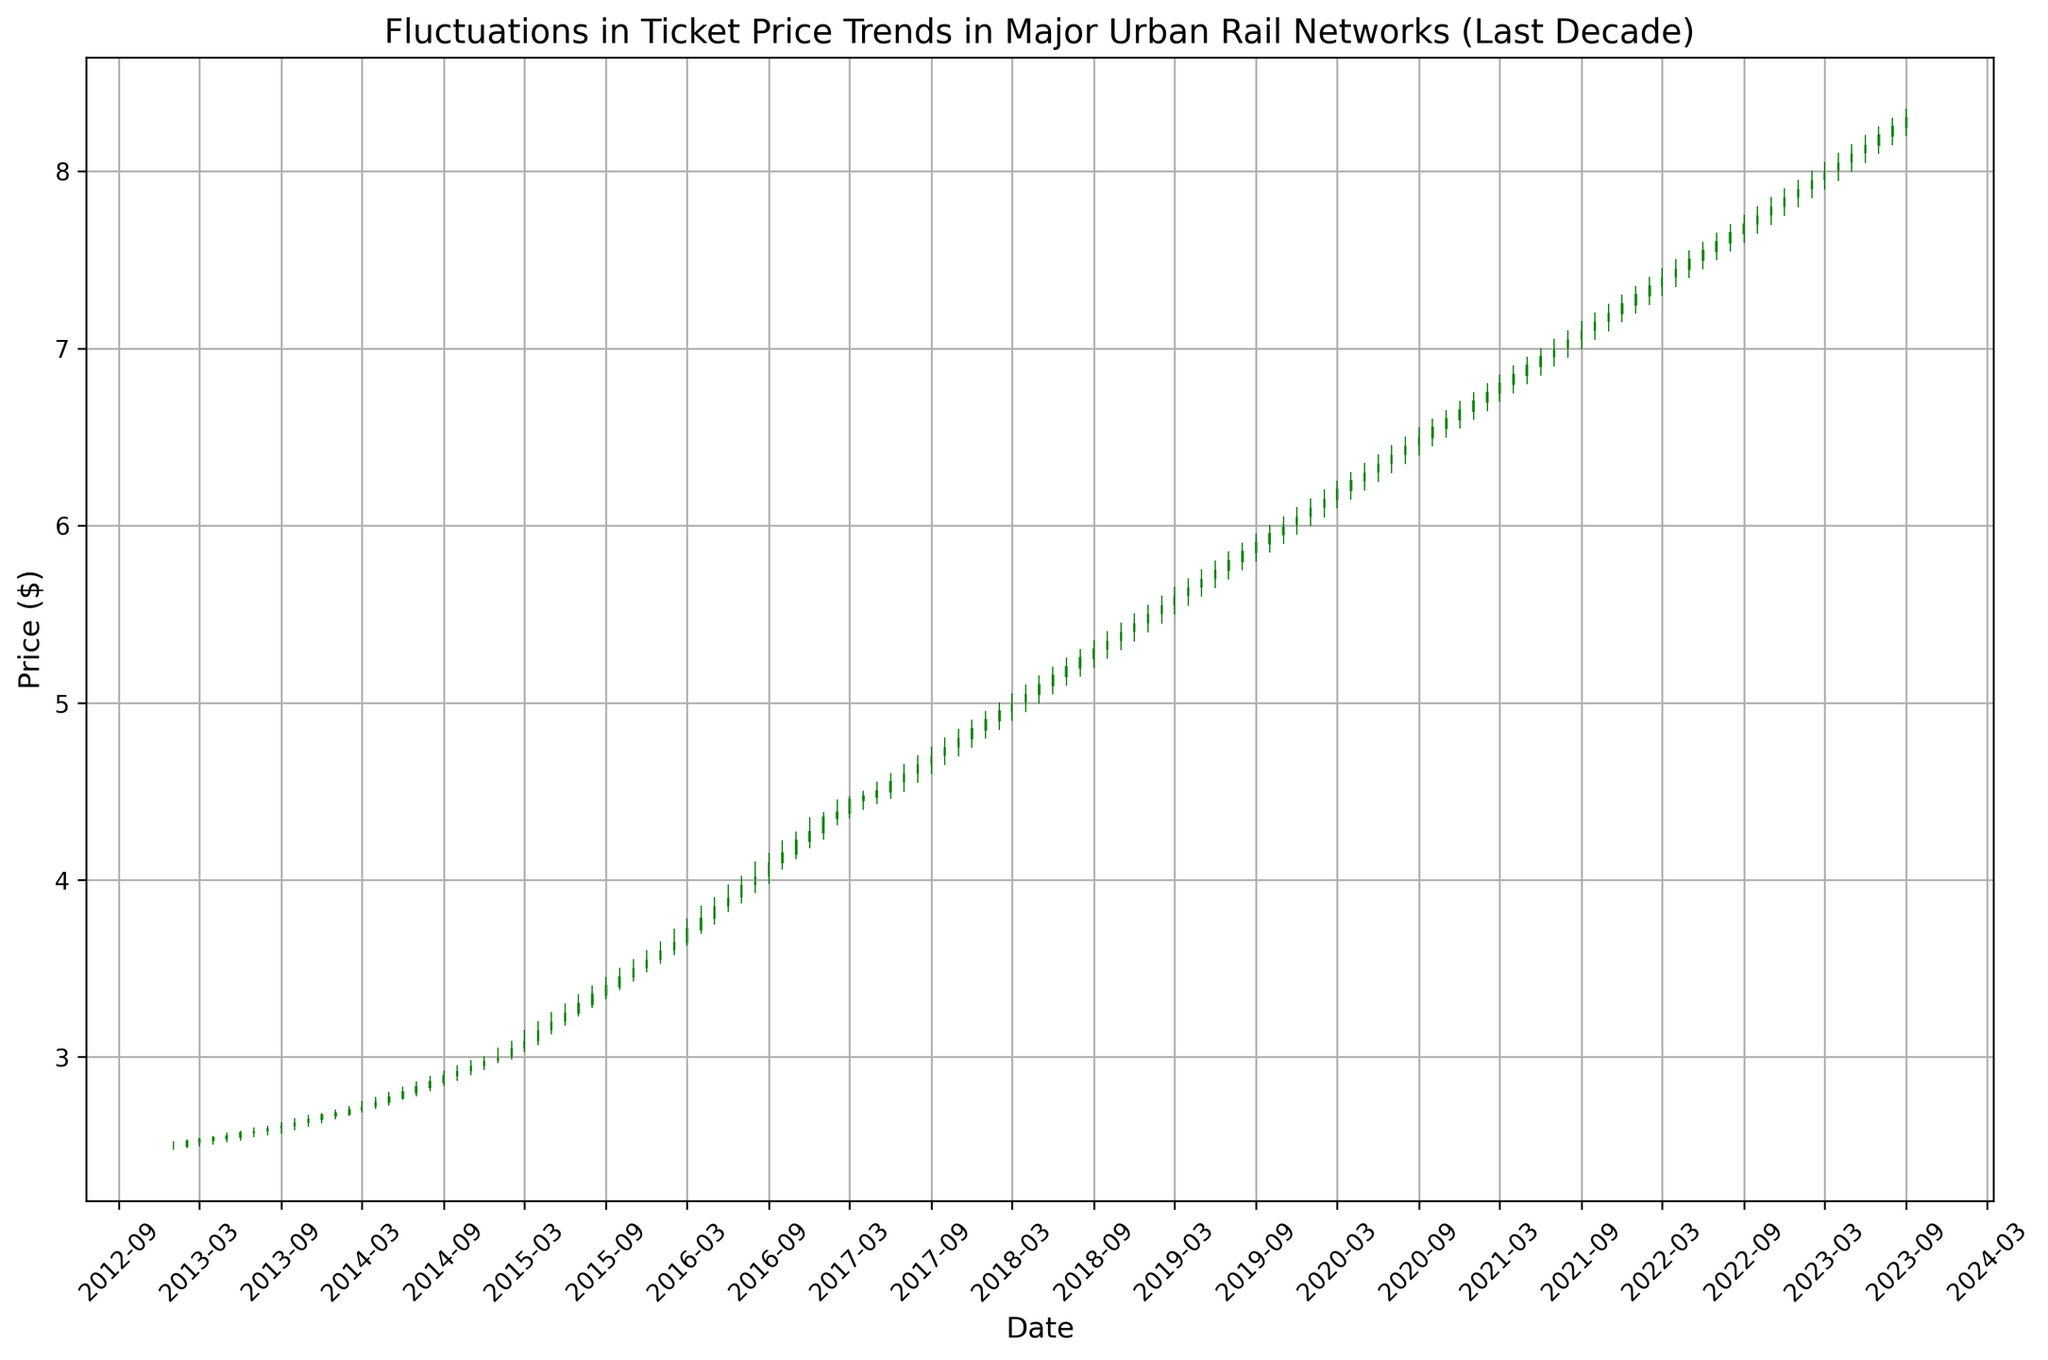What is the highest ticket price recorded in the data? To find the highest ticket price, observe the maximum value in the high-price candlestick plots, which visually represent peak prices for each month.
Answer: 8.35 Between January 2015 and January 2016, in which month did the closing ticket price experience the largest drop? Look at the closing prices for each month between January 2015 and January 2016 and identify the month with the largest downward difference between consecutive months.
Answer: March 2015 During which year did the ticket price first reach $6.00 as the closing price? Identify the month and year on the x-axis where the closing price candlestick part first touches $6.00. Cross-reference the date with the corresponding year.
Answer: 2019 Compare the ticket prices at the beginning and the end of the decade. Did the prices increase or decrease? Check the candlestick for the first month of 2013 and the candlestick for the last month of the dataset (September 2023). Compare their closing prices to determine the trend.
Answer: Increase What is the average closing price during the year 2018? Extract closing prices for each month in 2018: $4.85, $4.90, $5.00, $5.05, $5.10, $5.15, $5.20, $5.25, $5.30, $5.35, $5.40, and $5.45. Calculate their sum and divide by 12 to find the average.
Answer: $5.185 When did the ticket prices maintain a continuous increasing trend for the longest duration? Identify the duration of consecutive months where each month's closing price is higher than the previous month's closing price.
Answer: January 2017 to December 2018 What was the average ticket price increase per month between January 2020 and January 2021? See the closing prices at January 2020 ($6.10) and January 2021 ($6.70). Compute the difference and divide by the number of months in the duration, which is 12.
Answer: $0.05 Identify the month and year with the lowest low-ticket price within the decade. Identify the candlestick with the lowest value in its lower wick and reference the x-axis for the corresponding month and year.
Answer: January 2013 Did the closing price ever exactly match the high price in any month? If so, when? Inspect each candlestick plot and check if the top and the closing part (thicker part) of any candlestick coincide at the same point.
Answer: February 2015 